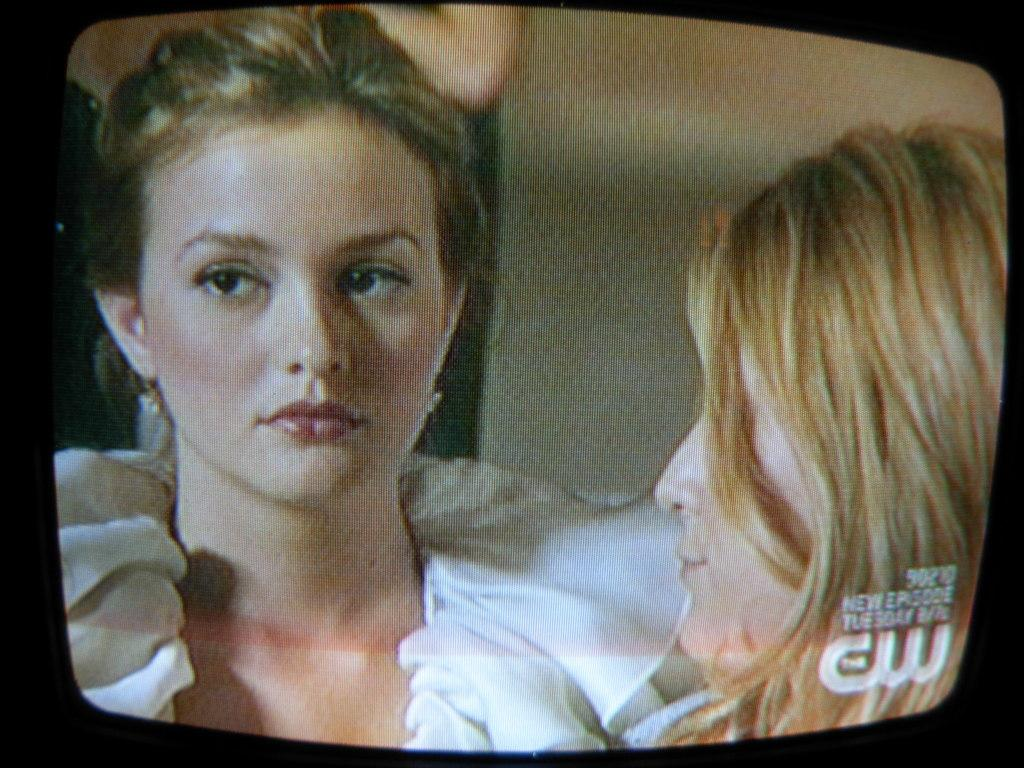What is the main object in the image? There is a television screen in the image. What can be seen on the television screen? Two women are visible on the television screen. How many flies can be seen on the television screen? There are no flies visible on the television screen; it only shows two women. What type of range is visible in the image? There is no range present in the image; it only features a television screen with two women. 